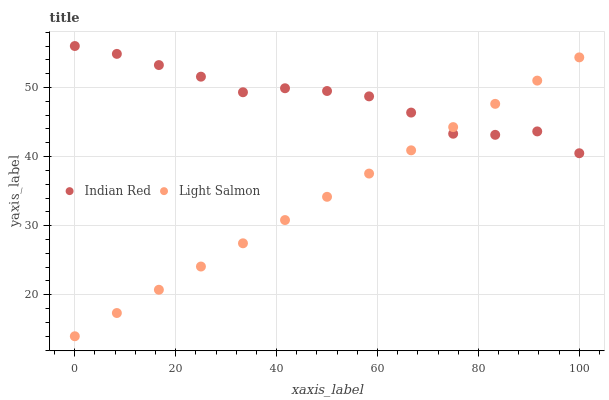Does Light Salmon have the minimum area under the curve?
Answer yes or no. Yes. Does Indian Red have the maximum area under the curve?
Answer yes or no. Yes. Does Indian Red have the minimum area under the curve?
Answer yes or no. No. Is Light Salmon the smoothest?
Answer yes or no. Yes. Is Indian Red the roughest?
Answer yes or no. Yes. Is Indian Red the smoothest?
Answer yes or no. No. Does Light Salmon have the lowest value?
Answer yes or no. Yes. Does Indian Red have the lowest value?
Answer yes or no. No. Does Indian Red have the highest value?
Answer yes or no. Yes. Does Light Salmon intersect Indian Red?
Answer yes or no. Yes. Is Light Salmon less than Indian Red?
Answer yes or no. No. Is Light Salmon greater than Indian Red?
Answer yes or no. No. 